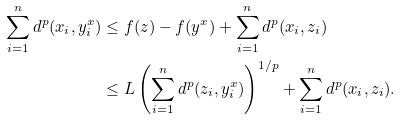<formula> <loc_0><loc_0><loc_500><loc_500>\sum _ { i = 1 } ^ { n } d ^ { p } ( x _ { i } , y ^ { x } _ { i } ) & \leq f ( z ) - f ( y ^ { x } ) + \sum _ { i = 1 } ^ { n } d ^ { p } ( x _ { i } , z _ { i } ) \\ & \leq L \left ( \sum _ { i = 1 } ^ { n } d ^ { p } ( z _ { i } , y ^ { x } _ { i } ) \right ) ^ { 1 / p } + \sum _ { i = 1 } ^ { n } d ^ { p } ( x _ { i } , z _ { i } ) .</formula> 